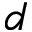<formula> <loc_0><loc_0><loc_500><loc_500>d</formula> 